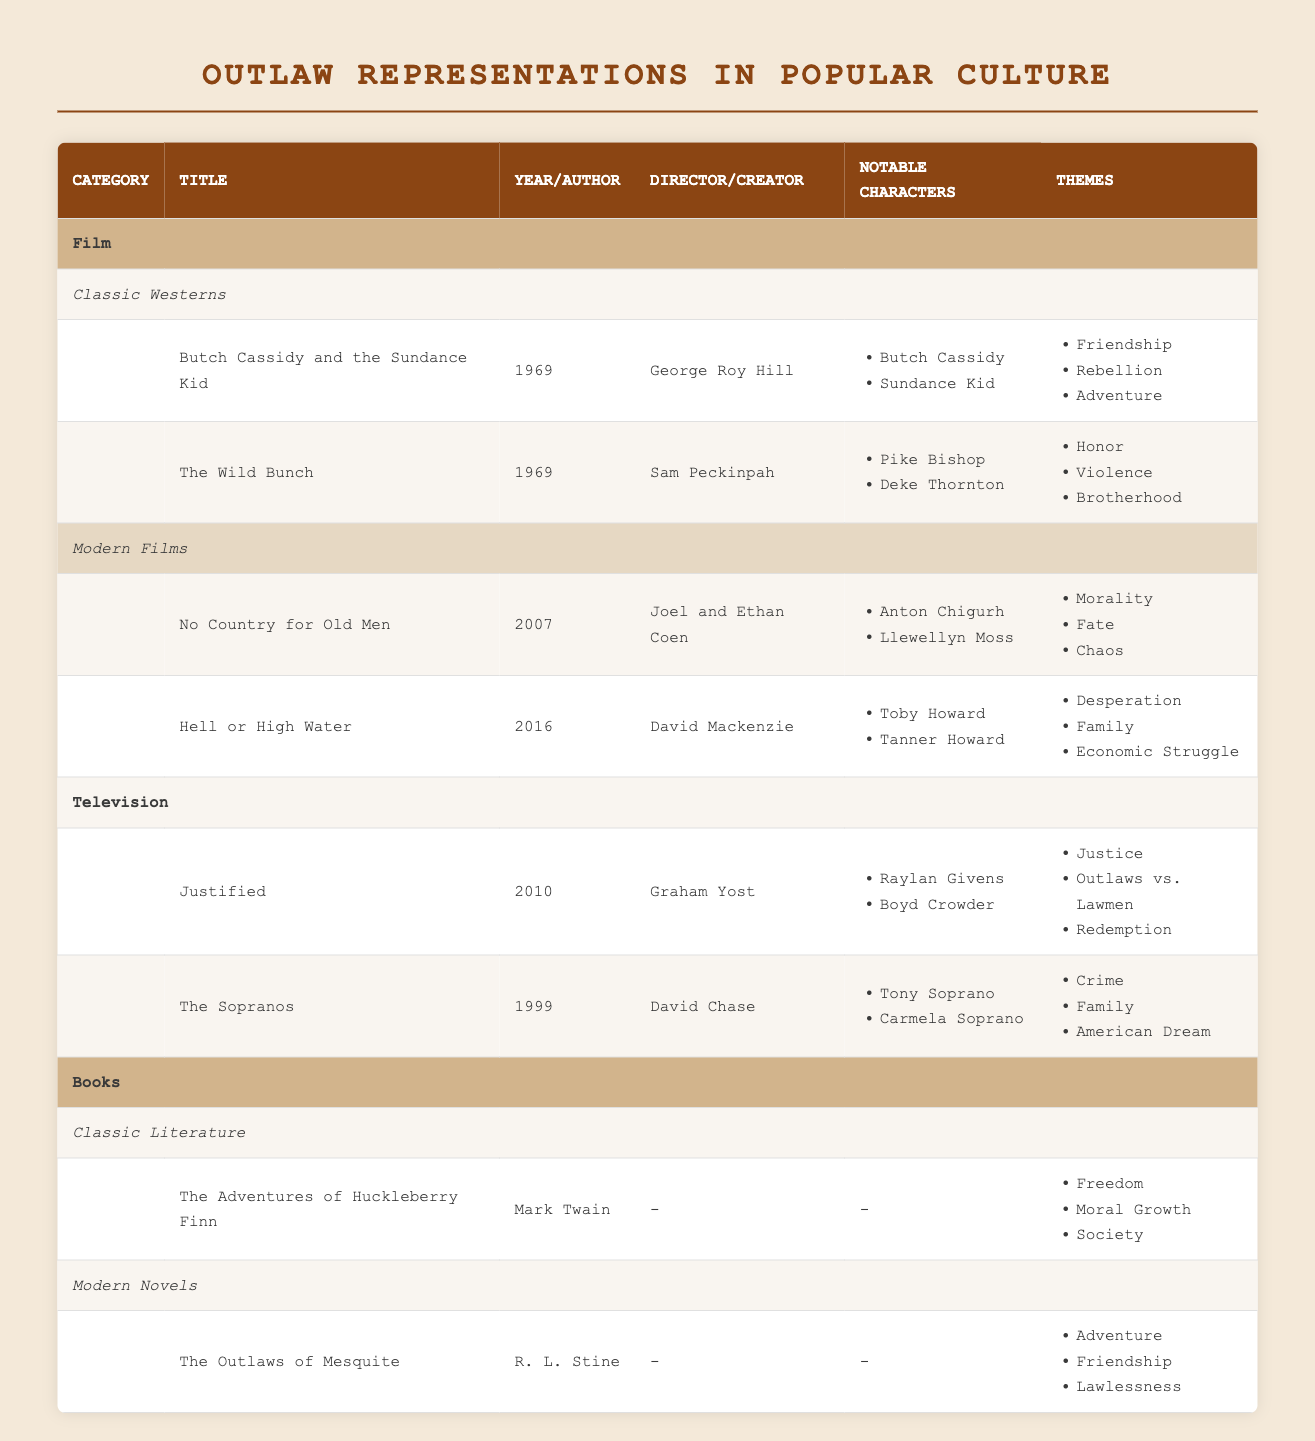What is the title of the film directed by George Roy Hill? The table lists a movie directed by George Roy Hill under the Classic Westerns category, which is "Butch Cassidy and the Sundance Kid."
Answer: Butch Cassidy and the Sundance Kid How many themes are presented in "No Country for Old Men"? The table indicates that "No Country for Old Men" has three themes: Morality, Fate, and Chaos, making a total of three themes.
Answer: 3 Is "The Wild Bunch" a modern film? The table categorizes "The Wild Bunch" under Classic Westerns, which indicates that it is not a modern film.
Answer: No Who are the notable characters in the series "Justified"? The notable characters listed in "Justified" are Raylan Givens and Boyd Crowder, as shown in the table.
Answer: Raylan Givens, Boyd Crowder What are the themes in "The Adventures of Huckleberry Finn"? According to the table, the themes of "The Adventures of Huckleberry Finn" are Freedom, Moral Growth, and Society, which can be counted for clarity.
Answer: Freedom, Moral Growth, Society Which film has a theme of "Desperation"? The theme of "Desperation" belongs to the film "Hell or High Water," as identified in the table.
Answer: Hell or High Water How many films are listed under Modern Films? The table lists two films under Modern Films: "No Country for Old Men" and "Hell or High Water." Therefore, the total is two films.
Answer: 2 Are there any titles listed under Classic Literature that were written by Mark Twain? The table confirms that "The Adventures of Huckleberry Finn," written by Mark Twain, is listed under Classic Literature, indicating this fact is true.
Answer: Yes What do the themes of "The Sopranos" predominantly represent? The themes listed for "The Sopranos" are Crime, Family, and American Dream, reflecting a complex representation of societal issues, making it a multifaceted show.
Answer: Crime, Family, American Dream 